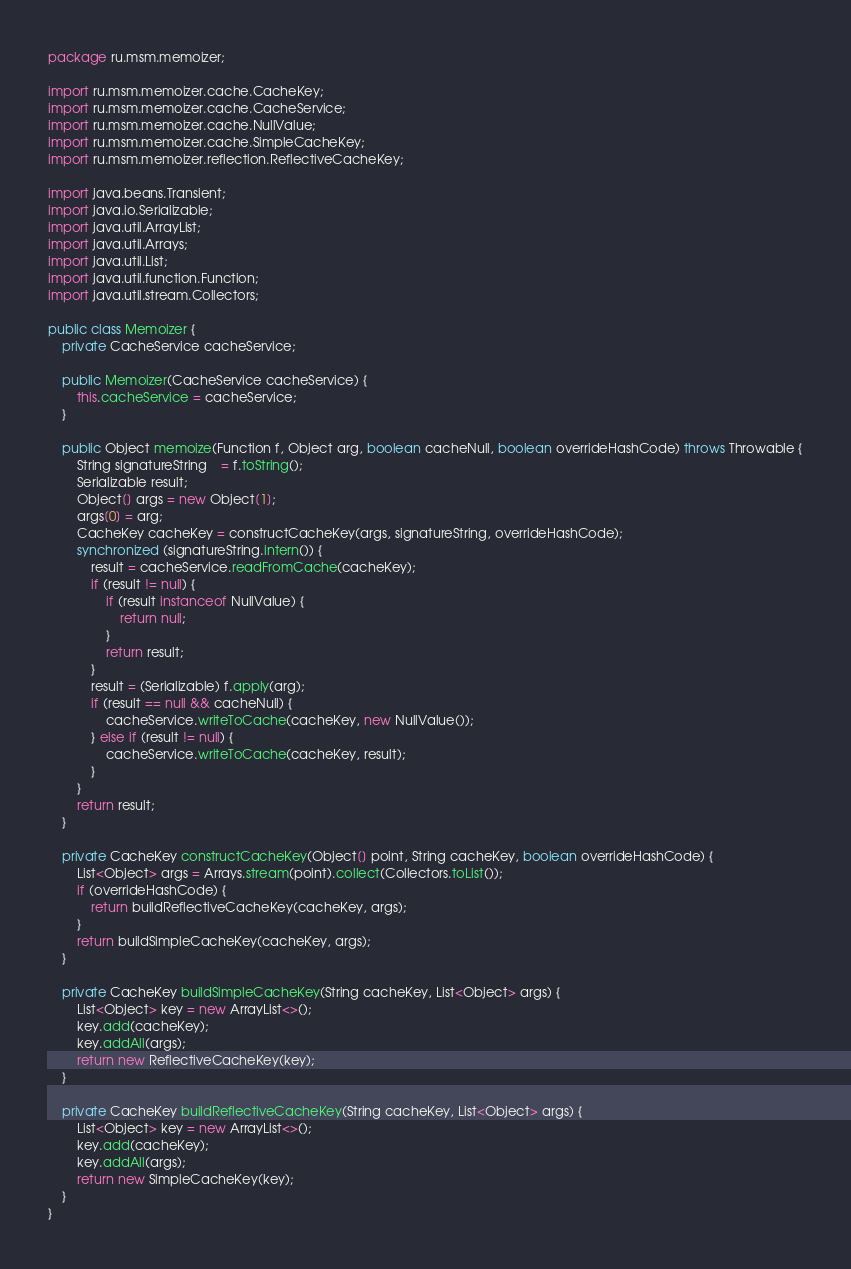<code> <loc_0><loc_0><loc_500><loc_500><_Java_>package ru.msm.memoizer;

import ru.msm.memoizer.cache.CacheKey;
import ru.msm.memoizer.cache.CacheService;
import ru.msm.memoizer.cache.NullValue;
import ru.msm.memoizer.cache.SimpleCacheKey;
import ru.msm.memoizer.reflection.ReflectiveCacheKey;

import java.beans.Transient;
import java.io.Serializable;
import java.util.ArrayList;
import java.util.Arrays;
import java.util.List;
import java.util.function.Function;
import java.util.stream.Collectors;

public class Memoizer {
    private CacheService cacheService;

    public Memoizer(CacheService cacheService) {
        this.cacheService = cacheService;
    }

    public Object memoize(Function f, Object arg, boolean cacheNull, boolean overrideHashCode) throws Throwable {
        String signatureString    = f.toString();
        Serializable result;
        Object[] args = new Object[1];
        args[0] = arg;
        CacheKey cacheKey = constructCacheKey(args, signatureString, overrideHashCode);
        synchronized (signatureString.intern()) {
            result = cacheService.readFromCache(cacheKey);
            if (result != null) {
                if (result instanceof NullValue) {
                    return null;
                }
                return result;
            }
            result = (Serializable) f.apply(arg);
            if (result == null && cacheNull) {
                cacheService.writeToCache(cacheKey, new NullValue());
            } else if (result != null) {
                cacheService.writeToCache(cacheKey, result);
            }
        }
        return result;
    }

    private CacheKey constructCacheKey(Object[] point, String cacheKey, boolean overrideHashCode) {
        List<Object> args = Arrays.stream(point).collect(Collectors.toList());
        if (overrideHashCode) {
            return buildReflectiveCacheKey(cacheKey, args);
        }
        return buildSimpleCacheKey(cacheKey, args);
    }

    private CacheKey buildSimpleCacheKey(String cacheKey, List<Object> args) {
        List<Object> key = new ArrayList<>();
        key.add(cacheKey);
        key.addAll(args);
        return new ReflectiveCacheKey(key);
    }

    private CacheKey buildReflectiveCacheKey(String cacheKey, List<Object> args) {
        List<Object> key = new ArrayList<>();
        key.add(cacheKey);
        key.addAll(args);
        return new SimpleCacheKey(key);
    }
}
</code> 